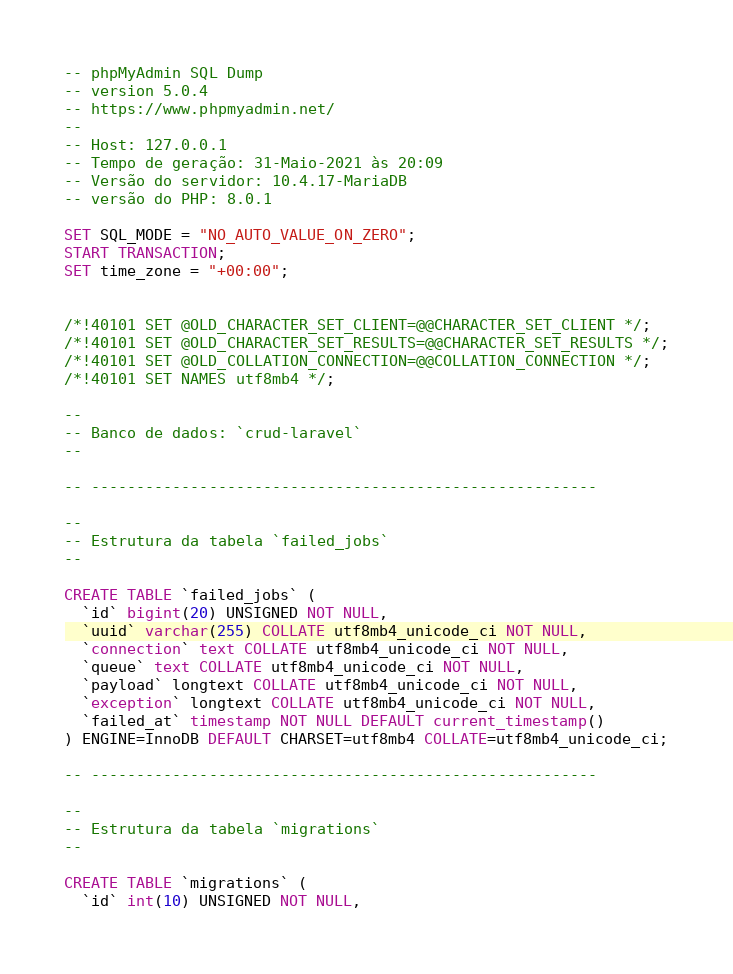Convert code to text. <code><loc_0><loc_0><loc_500><loc_500><_SQL_>-- phpMyAdmin SQL Dump
-- version 5.0.4
-- https://www.phpmyadmin.net/
--
-- Host: 127.0.0.1
-- Tempo de geração: 31-Maio-2021 às 20:09
-- Versão do servidor: 10.4.17-MariaDB
-- versão do PHP: 8.0.1

SET SQL_MODE = "NO_AUTO_VALUE_ON_ZERO";
START TRANSACTION;
SET time_zone = "+00:00";


/*!40101 SET @OLD_CHARACTER_SET_CLIENT=@@CHARACTER_SET_CLIENT */;
/*!40101 SET @OLD_CHARACTER_SET_RESULTS=@@CHARACTER_SET_RESULTS */;
/*!40101 SET @OLD_COLLATION_CONNECTION=@@COLLATION_CONNECTION */;
/*!40101 SET NAMES utf8mb4 */;

--
-- Banco de dados: `crud-laravel`
--

-- --------------------------------------------------------

--
-- Estrutura da tabela `failed_jobs`
--

CREATE TABLE `failed_jobs` (
  `id` bigint(20) UNSIGNED NOT NULL,
  `uuid` varchar(255) COLLATE utf8mb4_unicode_ci NOT NULL,
  `connection` text COLLATE utf8mb4_unicode_ci NOT NULL,
  `queue` text COLLATE utf8mb4_unicode_ci NOT NULL,
  `payload` longtext COLLATE utf8mb4_unicode_ci NOT NULL,
  `exception` longtext COLLATE utf8mb4_unicode_ci NOT NULL,
  `failed_at` timestamp NOT NULL DEFAULT current_timestamp()
) ENGINE=InnoDB DEFAULT CHARSET=utf8mb4 COLLATE=utf8mb4_unicode_ci;

-- --------------------------------------------------------

--
-- Estrutura da tabela `migrations`
--

CREATE TABLE `migrations` (
  `id` int(10) UNSIGNED NOT NULL,</code> 